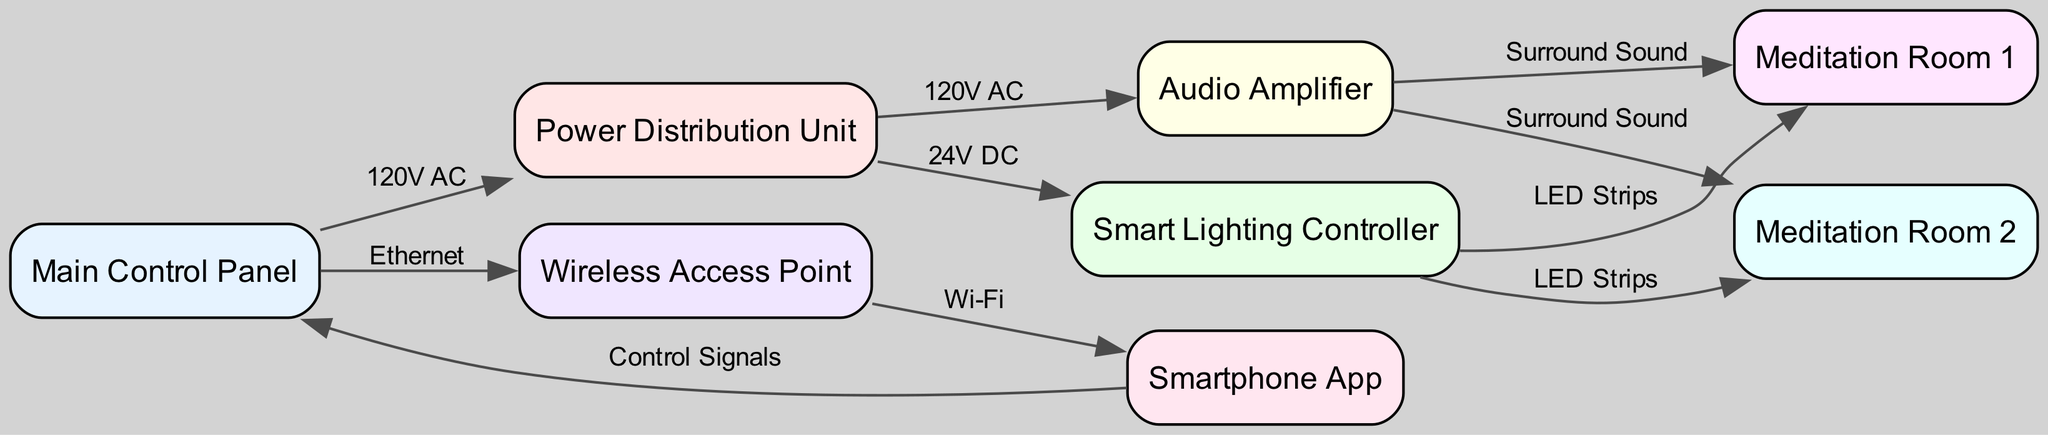What connects the Main Control Panel to the Power Distribution Unit? The edge labeled "120V AC" connects these two nodes, indicating that it transmits an alternating current voltage for power distribution.
Answer: 120V AC How many meditation rooms are included in the system? By examining the diagram, there are two distinct nodes labeled "Meditation Room 1" and "Meditation Room 2," confirming the presence of two rooms.
Answer: 2 What type of control signals are sent from the Smartphone App to the Main Control Panel? The diagram indicates control signals are used for communication, suggesting a command or settings adjustment from the app to the control panel.
Answer: Control Signals Which unit is connected to both meditation rooms for audio output? The Audio Amplifier connects to both meditation rooms, as designated by the edges labeled "Surround Sound," indicating that it outputs audio to both locations.
Answer: Audio Amplifier What voltage is supplied to the Smart Lighting Controller? The Power Distribution Unit supplies 24V DC to the Smart Lighting Controller, as shown by the edge connecting these two nodes labeled with the voltage type.
Answer: 24V DC Which node is the source for the Wi-Fi connection? The Wireless Access Point is identified as the source of the Wi-Fi connection, as it provides network connectivity to the Smartphone App via the edge labeled "Wi-Fi."
Answer: Wireless Access Point What is the primary function of the Smart Lighting Controller within the diagram? The Smart Lighting Controller is responsible for managing the LED Strips in both meditation rooms, as illustrated by the connections indicating control over lighting.
Answer: Manage LED Strips How does the Smartphone App interact with the system? The Smartphone App sends control signals to the Main Control Panel and receives Wi-Fi connectivity from the Wireless Access Point, acting as a remote control for the system.
Answer: Sends control signals and receives Wi-Fi What type of power is used for the Audio Amplifier? The Audio Amplifier is powered by 120V AC, indicated by the connection from the Power Distribution Unit labeled with this voltage type.
Answer: 120V AC 